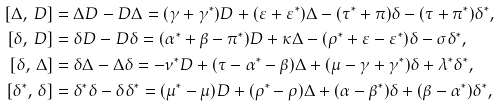Convert formula to latex. <formula><loc_0><loc_0><loc_500><loc_500>[ \Delta , \, D ] & = \Delta D - D \Delta = ( \gamma + \gamma ^ { \ast } ) D + ( \varepsilon + \varepsilon ^ { \ast } ) \Delta - ( \tau ^ { \ast } + \pi ) \delta - ( \tau + \pi ^ { \ast } ) \delta ^ { \ast } , \\ [ \delta , \, D ] & = \delta D - D \delta = ( \alpha ^ { \ast } + \beta - \pi ^ { \ast } ) D + \kappa \Delta - ( \rho ^ { \ast } + \varepsilon - \varepsilon ^ { \ast } ) \delta - \sigma \delta ^ { \ast } , \\ [ \delta , \, \Delta ] & = \delta \Delta - \Delta \delta = - \nu ^ { \ast } D + ( \tau - \alpha ^ { \ast } - \beta ) \Delta + ( \mu - \gamma + \gamma ^ { \ast } ) \delta + \lambda ^ { \ast } \delta ^ { \ast } , \\ [ \delta ^ { \ast } , \, \delta ] & = \delta ^ { \ast } \delta - \delta \delta ^ { \ast } = ( \mu ^ { \ast } - \mu ) D + ( \rho ^ { \ast } - \rho ) \Delta + ( \alpha - \beta ^ { \ast } ) \delta + ( \beta - \alpha ^ { \ast } ) \delta ^ { \ast } ,</formula> 